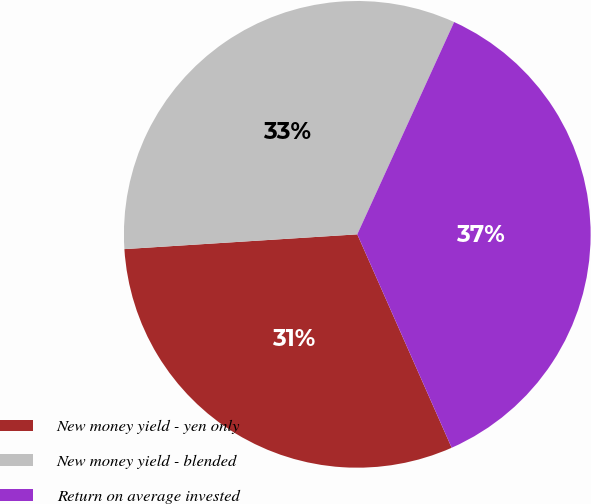<chart> <loc_0><loc_0><loc_500><loc_500><pie_chart><fcel>New money yield - yen only<fcel>New money yield - blended<fcel>Return on average invested<nl><fcel>30.62%<fcel>32.82%<fcel>36.56%<nl></chart> 